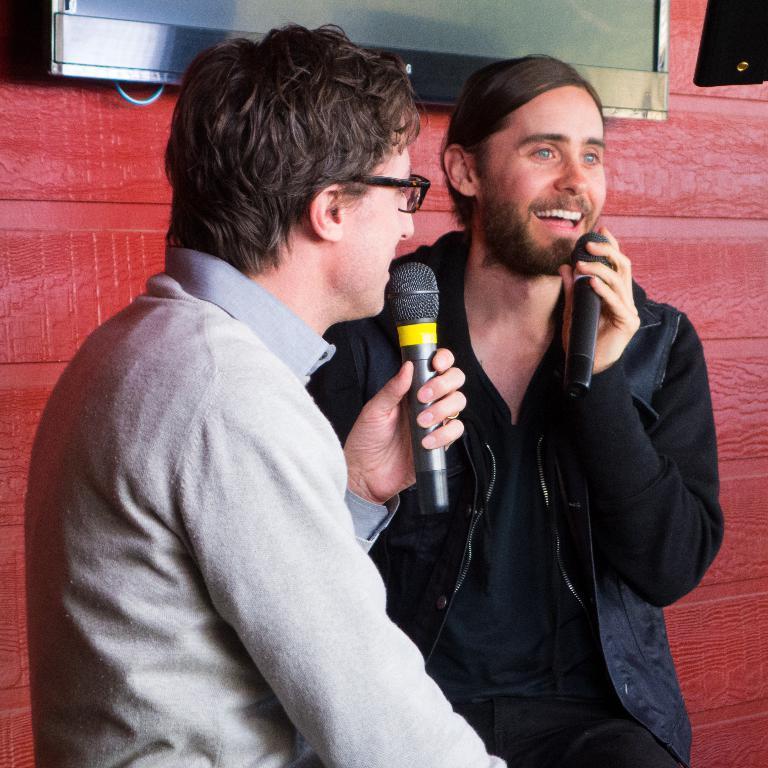Please provide a concise description of this image. In this image there are two man. In the right there is a man he wear black jacket he is smiling. In the left there is a man he hold a mic. In the background there is a TV and wall. 